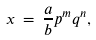<formula> <loc_0><loc_0><loc_500><loc_500>x \, = \, \frac { a } { b } p ^ { m } q ^ { n } ,</formula> 